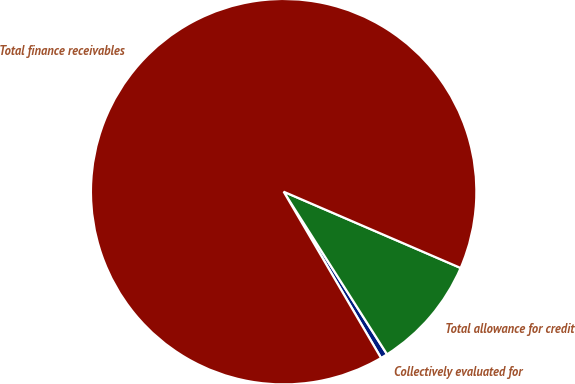Convert chart. <chart><loc_0><loc_0><loc_500><loc_500><pie_chart><fcel>Collectively evaluated for<fcel>Total allowance for credit<fcel>Total finance receivables<nl><fcel>0.58%<fcel>9.51%<fcel>89.91%<nl></chart> 